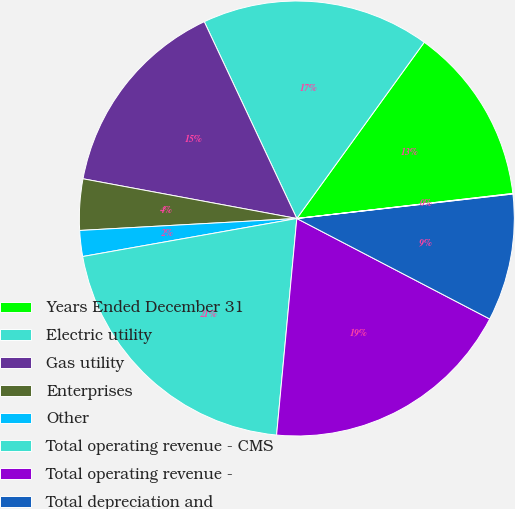Convert chart to OTSL. <chart><loc_0><loc_0><loc_500><loc_500><pie_chart><fcel>Years Ended December 31<fcel>Electric utility<fcel>Gas utility<fcel>Enterprises<fcel>Other<fcel>Total operating revenue - CMS<fcel>Total operating revenue -<fcel>Total depreciation and<fcel>Total income from equity<nl><fcel>13.2%<fcel>16.96%<fcel>15.08%<fcel>3.8%<fcel>1.92%<fcel>20.72%<fcel>18.84%<fcel>9.44%<fcel>0.04%<nl></chart> 